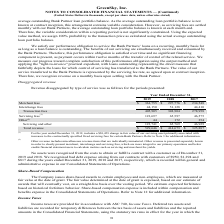According to Greensky's financial document, How much was the included change in fair value of the company's servicing asset included in its servicing fees? According to the financial document, 30,459 (in thousands). The relevant text states: "For the year ended December 31, 2019, includes a $30,459 change in fair value of our servicing asset primarily associated with increases to the contractuall..." Also, What does other revenue include? miscellaneous revenue items that are individually immaterial. Other revenue is presented separately herein in order to clearly present merchant, interchange and servicing fees. The document states: "(2) Other revenue includes miscellaneous revenue items that are individually immaterial. Other revenue is presented separately herein in order to clea..." Also, Which years does the table provide information for Revenue disaggregated by type of service? The document contains multiple relevant values: 2019, 2018, 2017. From the document: "Year Ended December 31, 2019 2018 2017 Merchant fees $ 361,755 $ 297,776 $ 234,548 Interchange fees 44,150 51,128 44,410 Transaction fees Year Ended D..." Also, How many years did Interchange fees exceed $50,000 thousand? Based on the analysis, there are 1 instances. The counting process: 2018. Also, can you calculate: What was the change in the transaction fees between 2017 and 2019? Based on the calculation: 405,905-278,958, the result is 126947 (in thousands). This is based on the information: "50 51,128 44,410 Transaction fees 405,905 348,904 278,958 Servicing fees (1) 123,697 65,597 46,575 Other (2) 44 172 354 Servicing and other 123,741 65,769 46 change fees 44,150 51,128 44,410 Transacti..." The key data points involved are: 278,958, 405,905. Also, can you calculate: What was the percentage change in the total revenue between 2018 and 2019? To answer this question, I need to perform calculations using the financial data. The calculation is: (529,646-414,673)/414,673, which equals 27.73 (percentage). This is based on the information: "g and other 123,741 65,769 46,929 Total revenue $ 529,646 $ 414,673 $ 325,887 r 123,741 65,769 46,929 Total revenue $ 529,646 $ 414,673 $ 325,887..." The key data points involved are: 414,673, 529,646. 